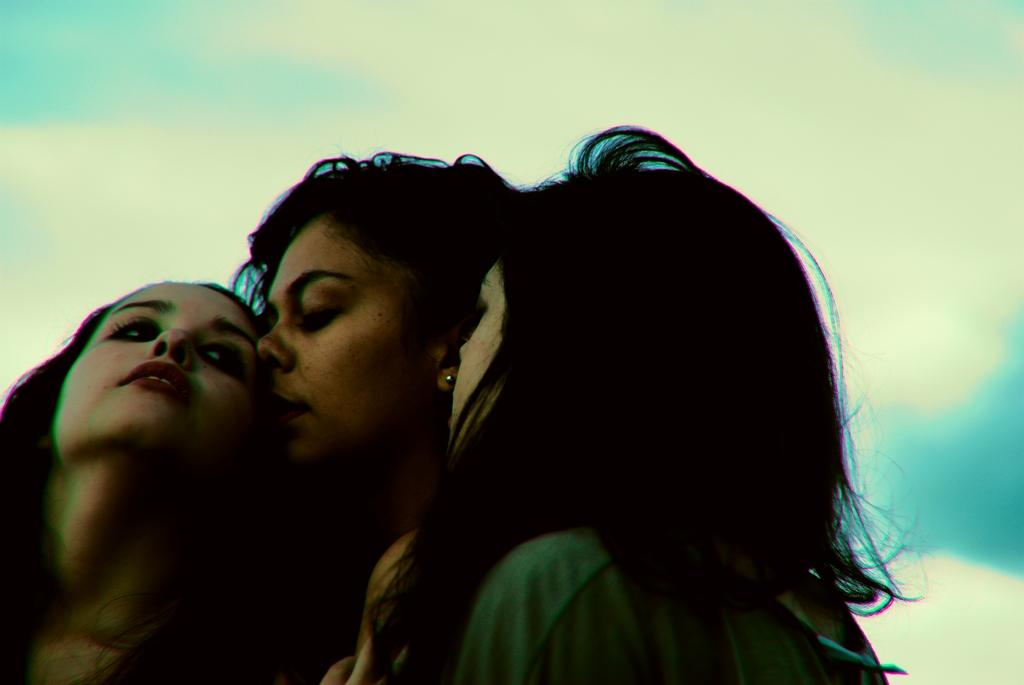How many people are in the image? There are three girls in the image. What can be seen in the background of the image? The background of the image includes a blue sky. Are there any additional features in the sky? Yes, there are clouds visible in the sky. What type of iron can be seen in the image? There is no iron present in the image. Is there a drain visible in the image? No, there is no drain visible in the image. 